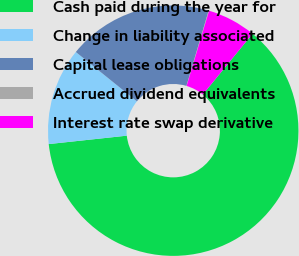Convert chart. <chart><loc_0><loc_0><loc_500><loc_500><pie_chart><fcel>Cash paid during the year for<fcel>Change in liability associated<fcel>Capital lease obligations<fcel>Accrued dividend equivalents<fcel>Interest rate swap derivative<nl><fcel>62.37%<fcel>12.52%<fcel>18.75%<fcel>0.06%<fcel>6.29%<nl></chart> 